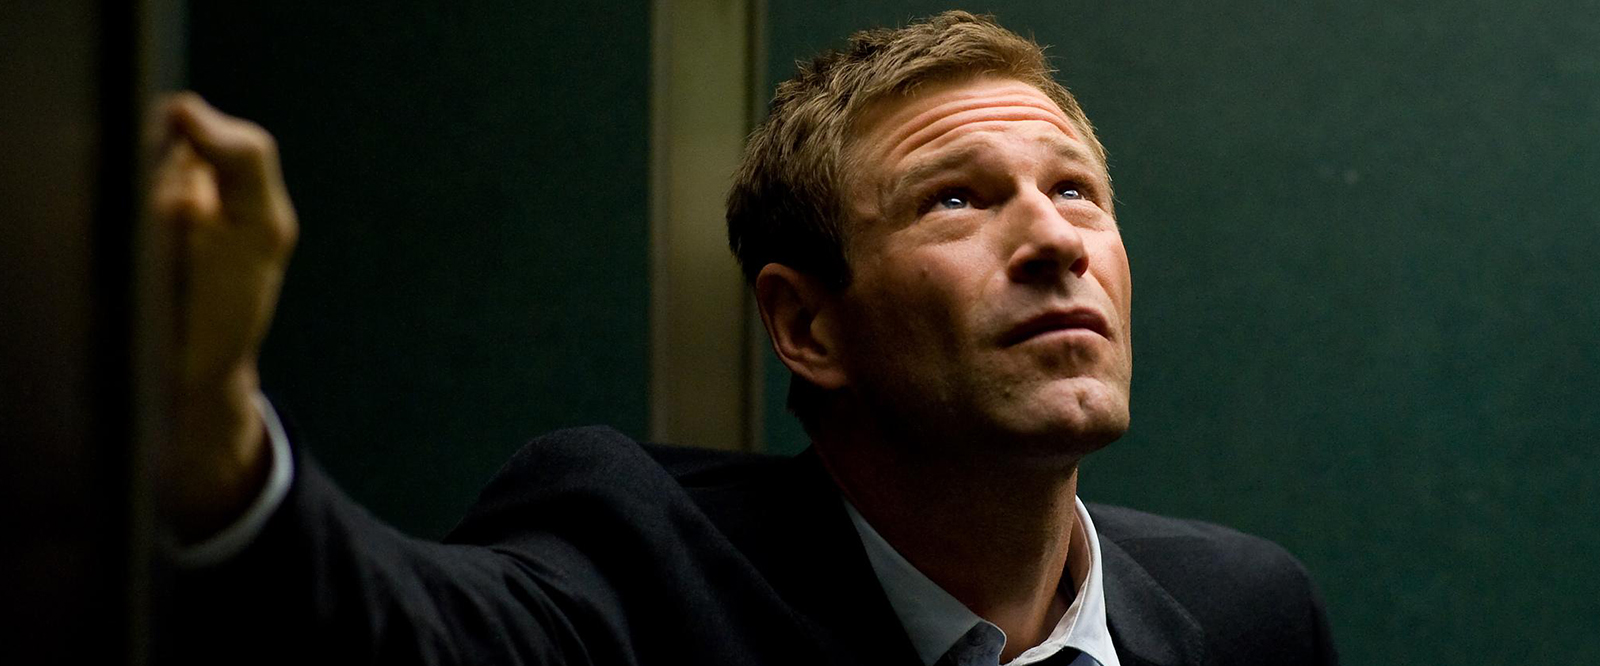What are the key elements in this picture? The image captures a person who appears to be introspective or concerned, possibly in a moment of decision. He's dressed in formal attire, wearing a dark suit and tie. His hand lightly resting on a green wall and gripping a railing suggests he is on a higher level, potentially a balcony or near a staircase. The ambient lighting casts soft shadows on his face, emphasizing his expression. His gaze is directed upwards, implying contemplation or observation of something out of view. 